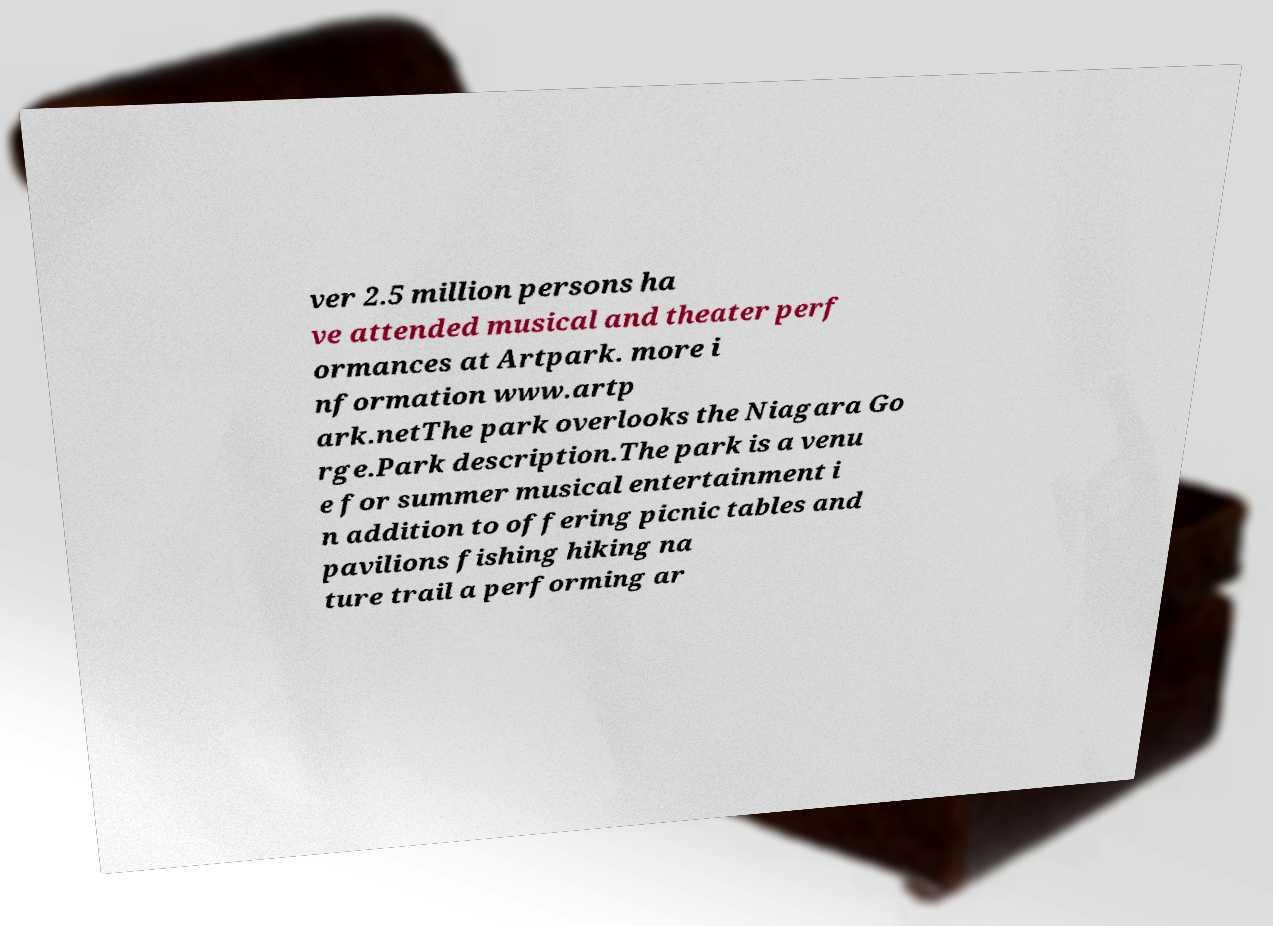Could you assist in decoding the text presented in this image and type it out clearly? ver 2.5 million persons ha ve attended musical and theater perf ormances at Artpark. more i nformation www.artp ark.netThe park overlooks the Niagara Go rge.Park description.The park is a venu e for summer musical entertainment i n addition to offering picnic tables and pavilions fishing hiking na ture trail a performing ar 